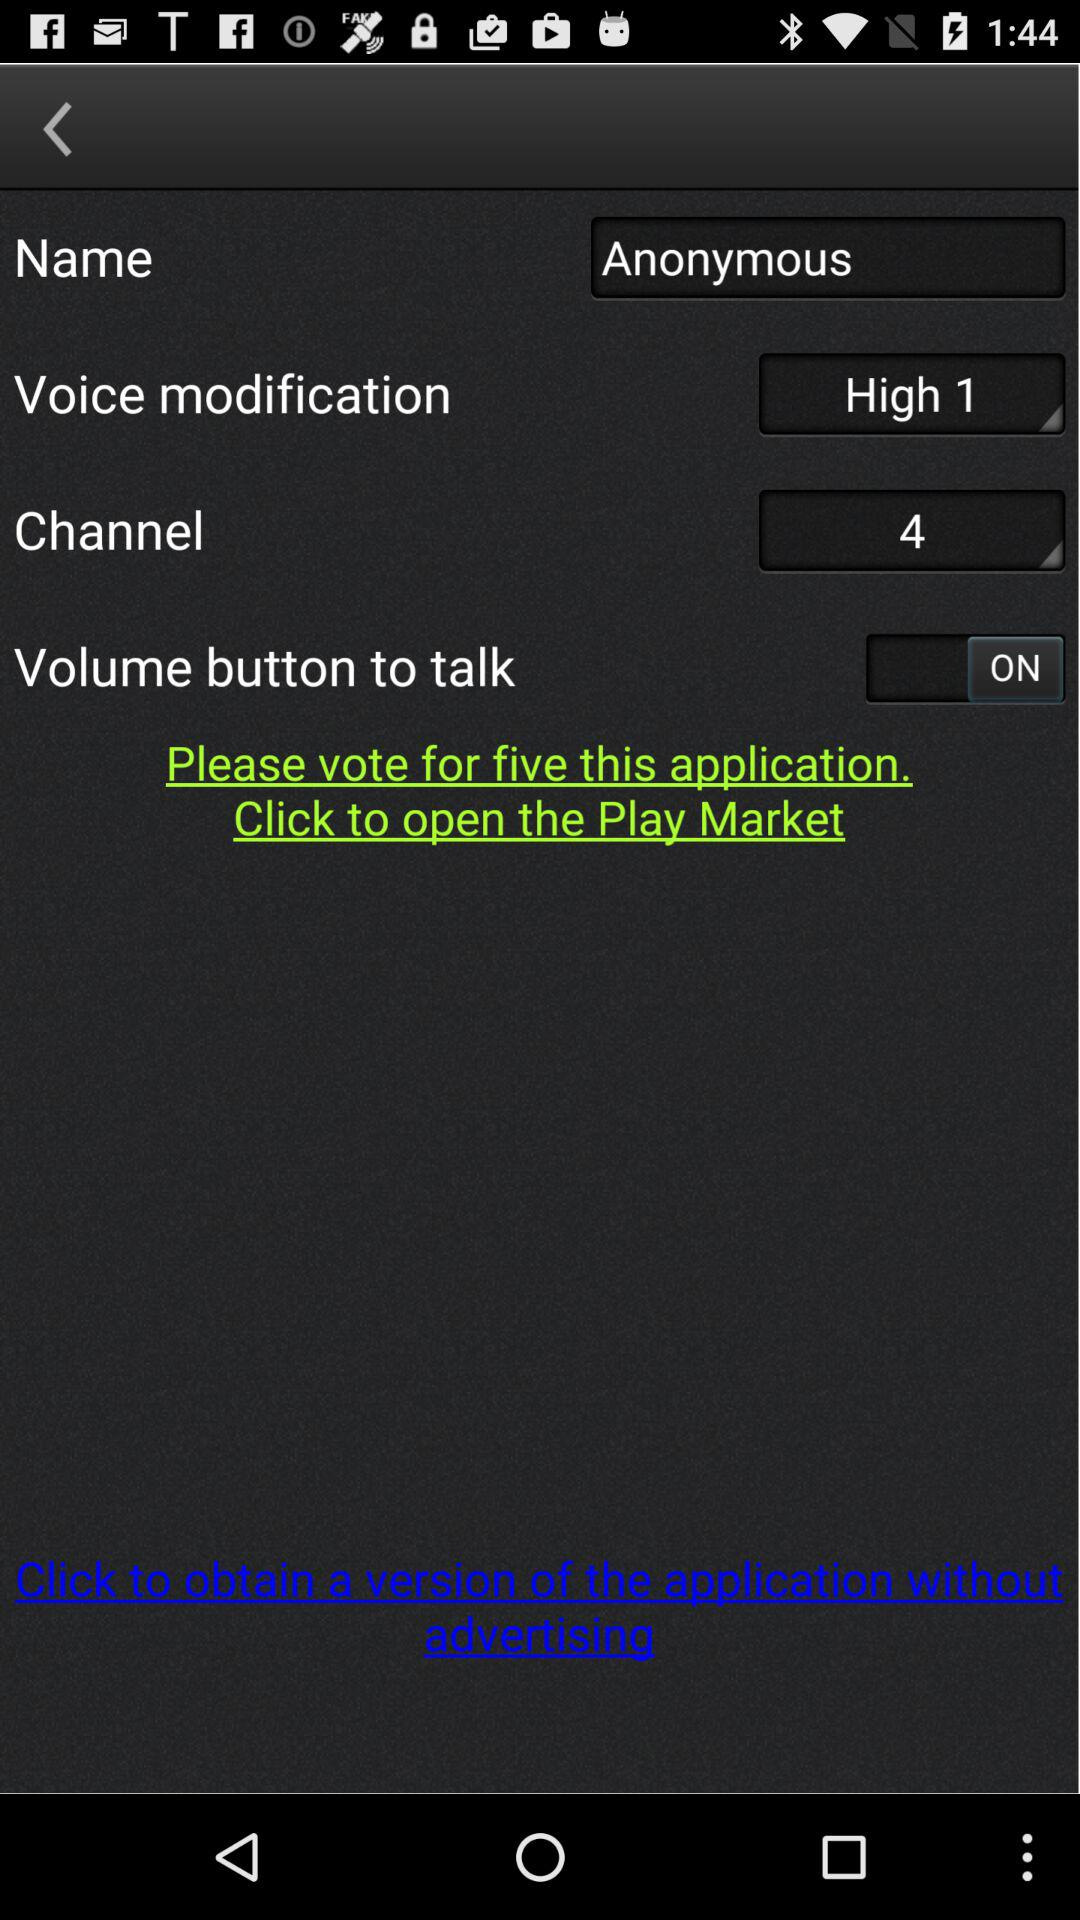What is the given name? The given name is Anonymous. 